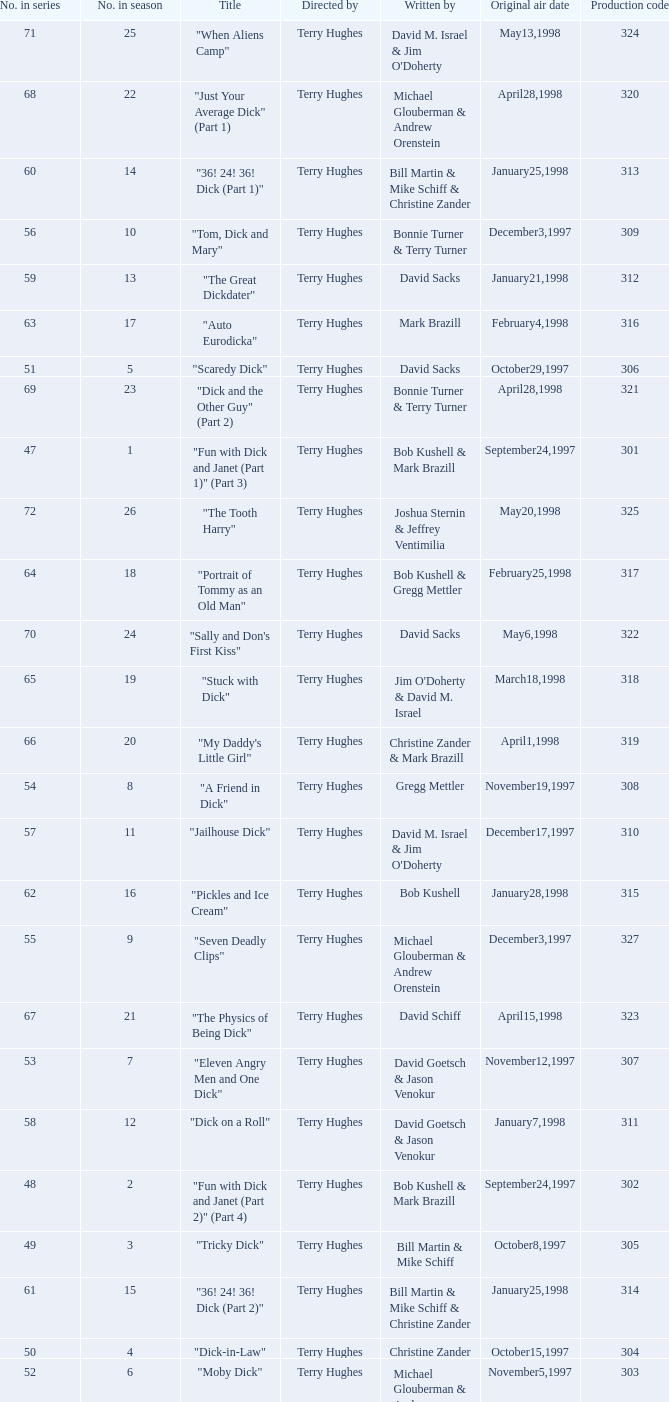Who were the writers of the episode titled "Tricky Dick"? Bill Martin & Mike Schiff. 